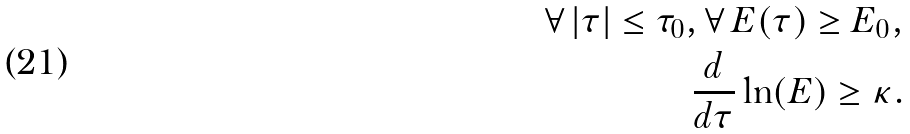<formula> <loc_0><loc_0><loc_500><loc_500>\forall \, | \tau | \leq \tau _ { 0 } , \forall \, E ( \tau ) \geq E _ { 0 } , \\ \frac { d } { d \tau } \ln ( E ) \geq \kappa .</formula> 